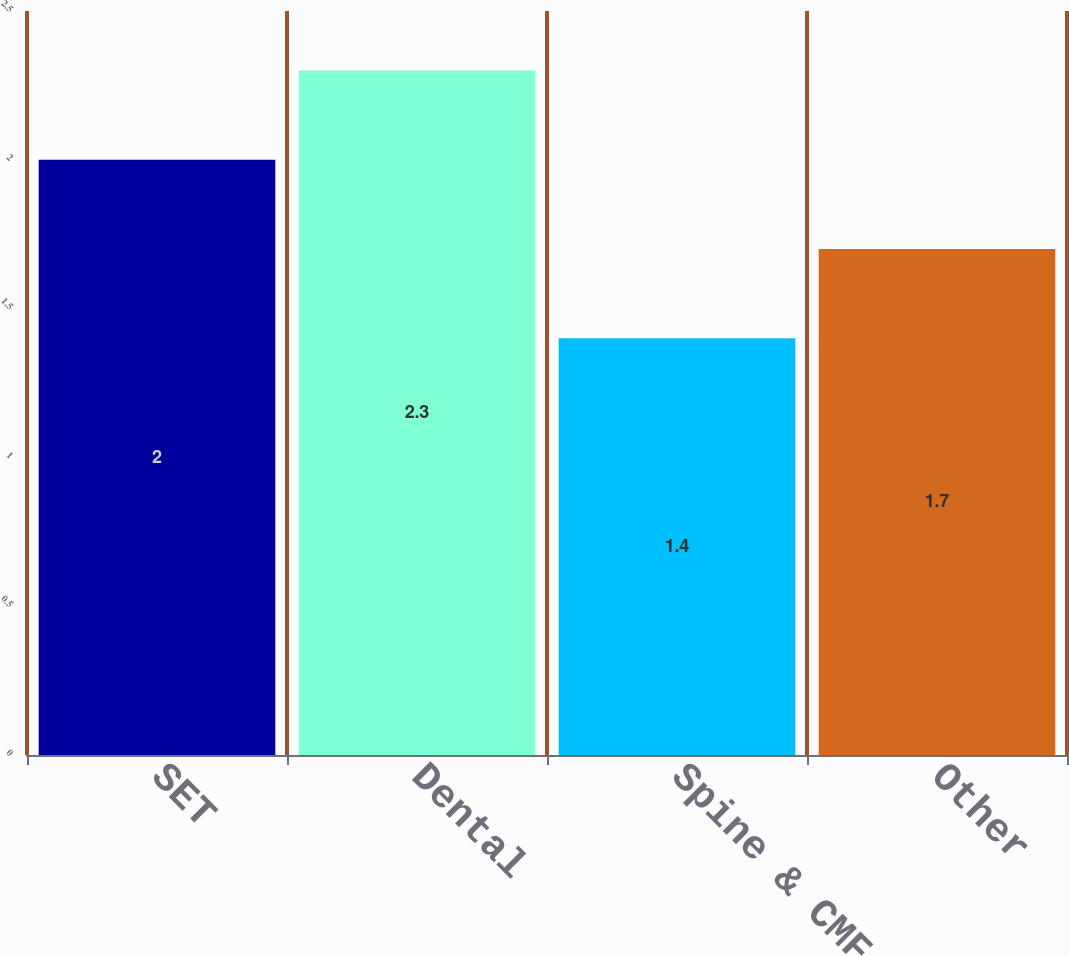<chart> <loc_0><loc_0><loc_500><loc_500><bar_chart><fcel>SET<fcel>Dental<fcel>Spine & CMF<fcel>Other<nl><fcel>2<fcel>2.3<fcel>1.4<fcel>1.7<nl></chart> 